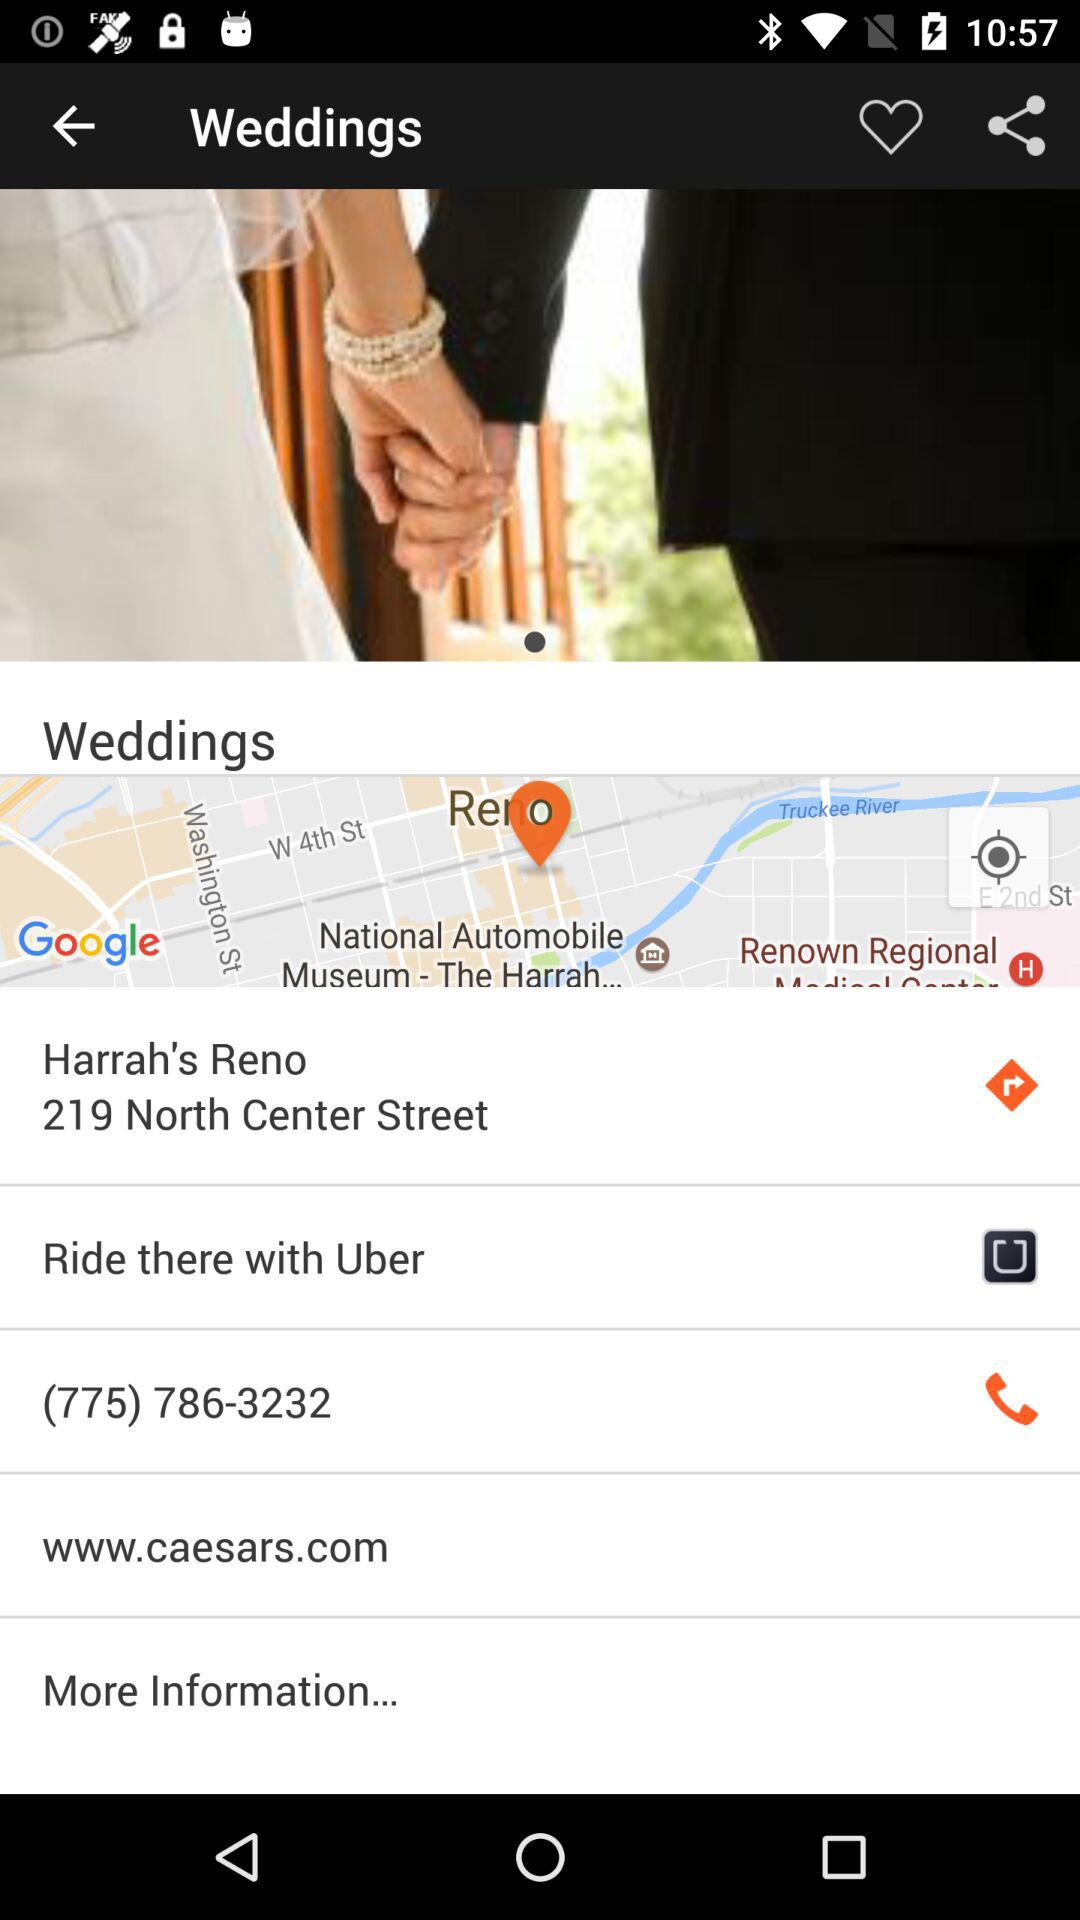What is the address? The address is "Harrah's Reno 219 North Center Street". 